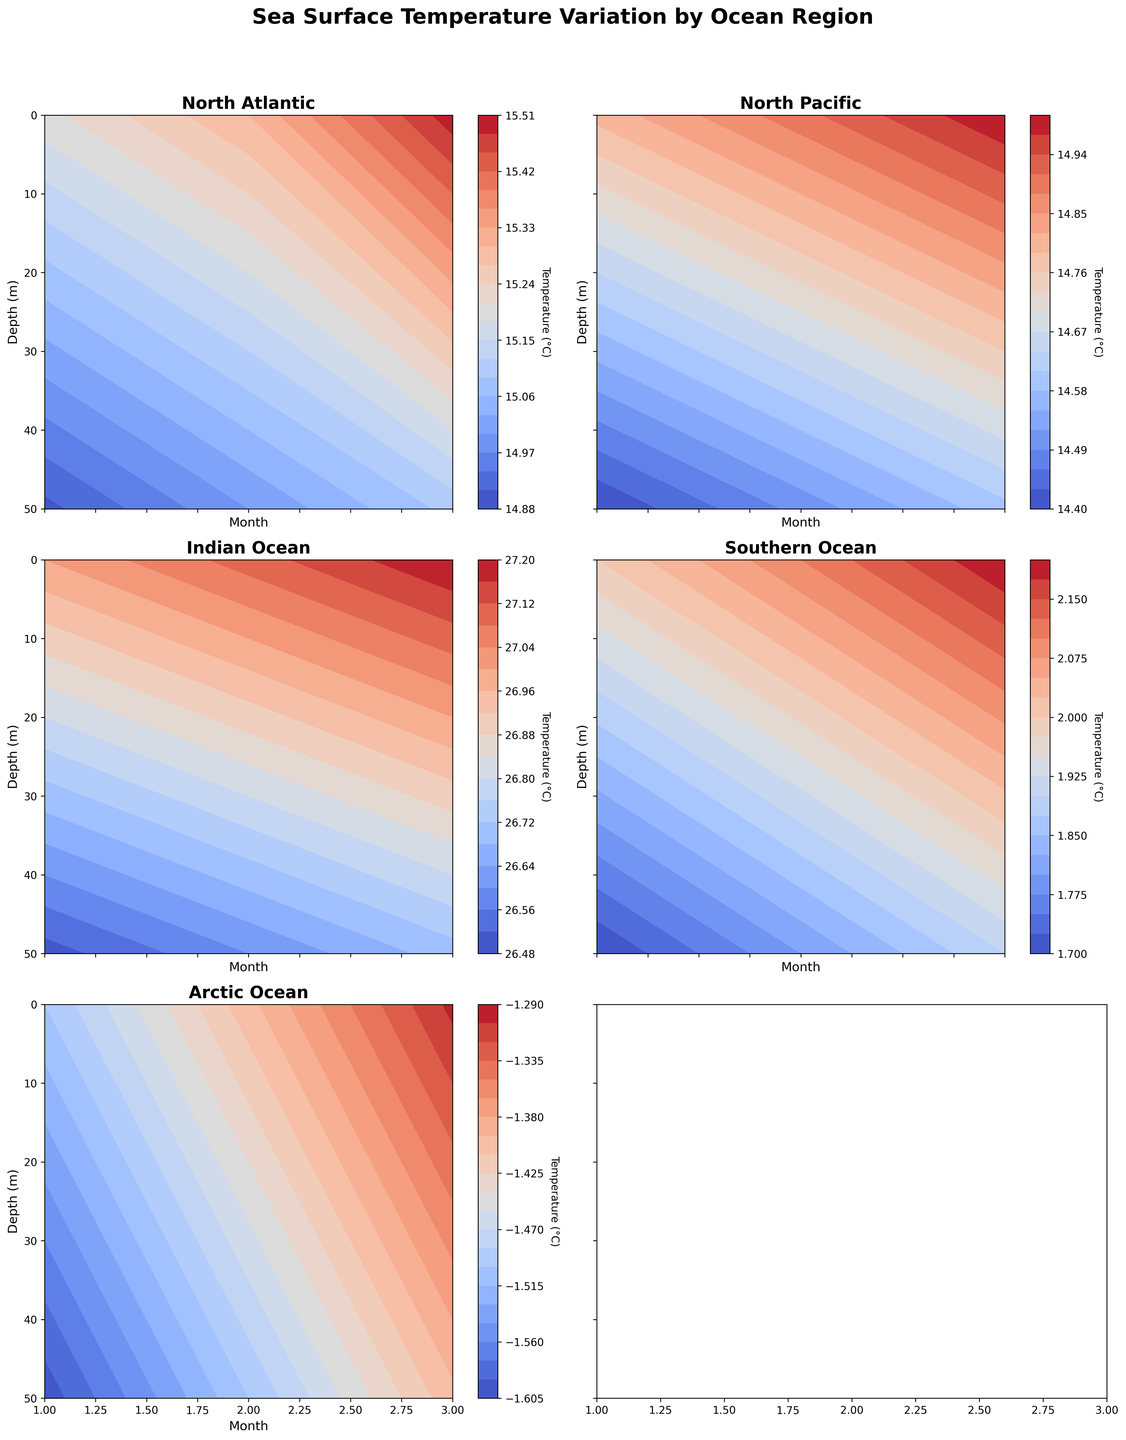What does the title of the figure indicate? The title of the figure, "Sea Surface Temperature Variation by Ocean Region," indicates that the figure depicts changes in sea surface temperatures across different ocean regions. This helps the viewer understand the data context.
Answer: "Sea Surface Temperature Variation by Ocean Region" Which region shows the highest surface temperature in March 2000? The region with the highest surface temperature can be identified by looking at the "March" column in the first (0 meters) depth layer for each region. The Indian Ocean shows the highest value at 27.2°C.
Answer: Indian Ocean For the North Atlantic region, what is the temperature difference between 0 meters and 50 meters depth in February 2000? The temperature at 0 meters depth in February for the North Atlantic is 15.3°C, and at 50 meters depth it is 15.0°C. The temperature difference is 15.3 - 15.0 = 0.3°C.
Answer: 0.3°C Which region shows the lowest temperature at 50 meters depth in January 2000? By examining the "January" column for the 50 meters depth layer in each region, the Arctic Ocean has the lowest temperature of -1.6°C.
Answer: Arctic Ocean How does the temperature change with depth in the Southern Ocean in March 2000? In the Southern Ocean in March, temperatures at 0 meters depth and 50 meters depth are 2.2°C and 1.9°C, respectively, showing a temperature decrease with depth.
Answer: Decreases Which region has the most significant temperature difference between January and March at 50 meters depth? To find the region with the most substantial temperature change, calculate the difference for each region at 50 meters depth between January and March. The Indian Ocean has the largest change with (26.7 - 26.5) = 0.2°C.
Answer: Indian Ocean Between the North Pacific and Southern Ocean, which one shows a greater variation in temperature at 0 meters depth between January and March? The North Pacific temperature varies from 14.8°C to 15.0°C (a 0.2°C change) while the Southern Ocean varies from 2.0°C to 2.2°C (also a 0.2°C change). Both show the same variation.
Answer: Both show the same variation Is there any region where the surface temperature is consistently above 25°C throughout the observed period? By examining the surface temperatures (0 meters depth) for each region across all months, only the Indian Ocean has consistently high temperatures above 25°C.
Answer: Indian Ocean What's the overall temperature trend with increasing depth in the Arctic Ocean? The Arctic Ocean shows slightly lower temperatures at 50 meters depth compared to 0 meters depth for each month, indicating temperatures slightly decrease with depth.
Answer: Slightly decreases 